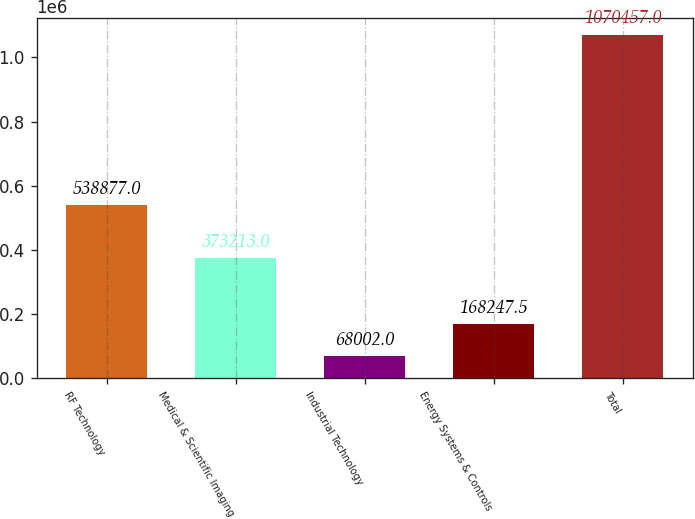<chart> <loc_0><loc_0><loc_500><loc_500><bar_chart><fcel>RF Technology<fcel>Medical & Scientific Imaging<fcel>Industrial Technology<fcel>Energy Systems & Controls<fcel>Total<nl><fcel>538877<fcel>373213<fcel>68002<fcel>168248<fcel>1.07046e+06<nl></chart> 